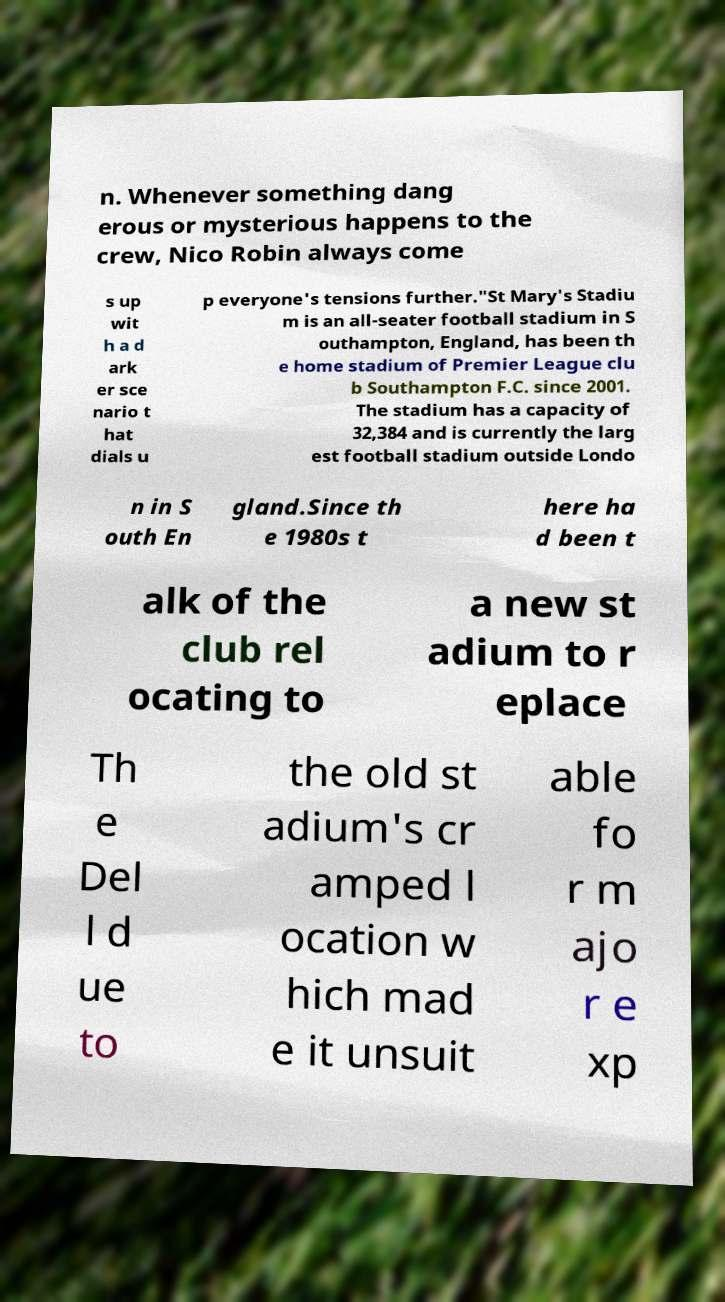Could you extract and type out the text from this image? n. Whenever something dang erous or mysterious happens to the crew, Nico Robin always come s up wit h a d ark er sce nario t hat dials u p everyone's tensions further."St Mary's Stadiu m is an all-seater football stadium in S outhampton, England, has been th e home stadium of Premier League clu b Southampton F.C. since 2001. The stadium has a capacity of 32,384 and is currently the larg est football stadium outside Londo n in S outh En gland.Since th e 1980s t here ha d been t alk of the club rel ocating to a new st adium to r eplace Th e Del l d ue to the old st adium's cr amped l ocation w hich mad e it unsuit able fo r m ajo r e xp 